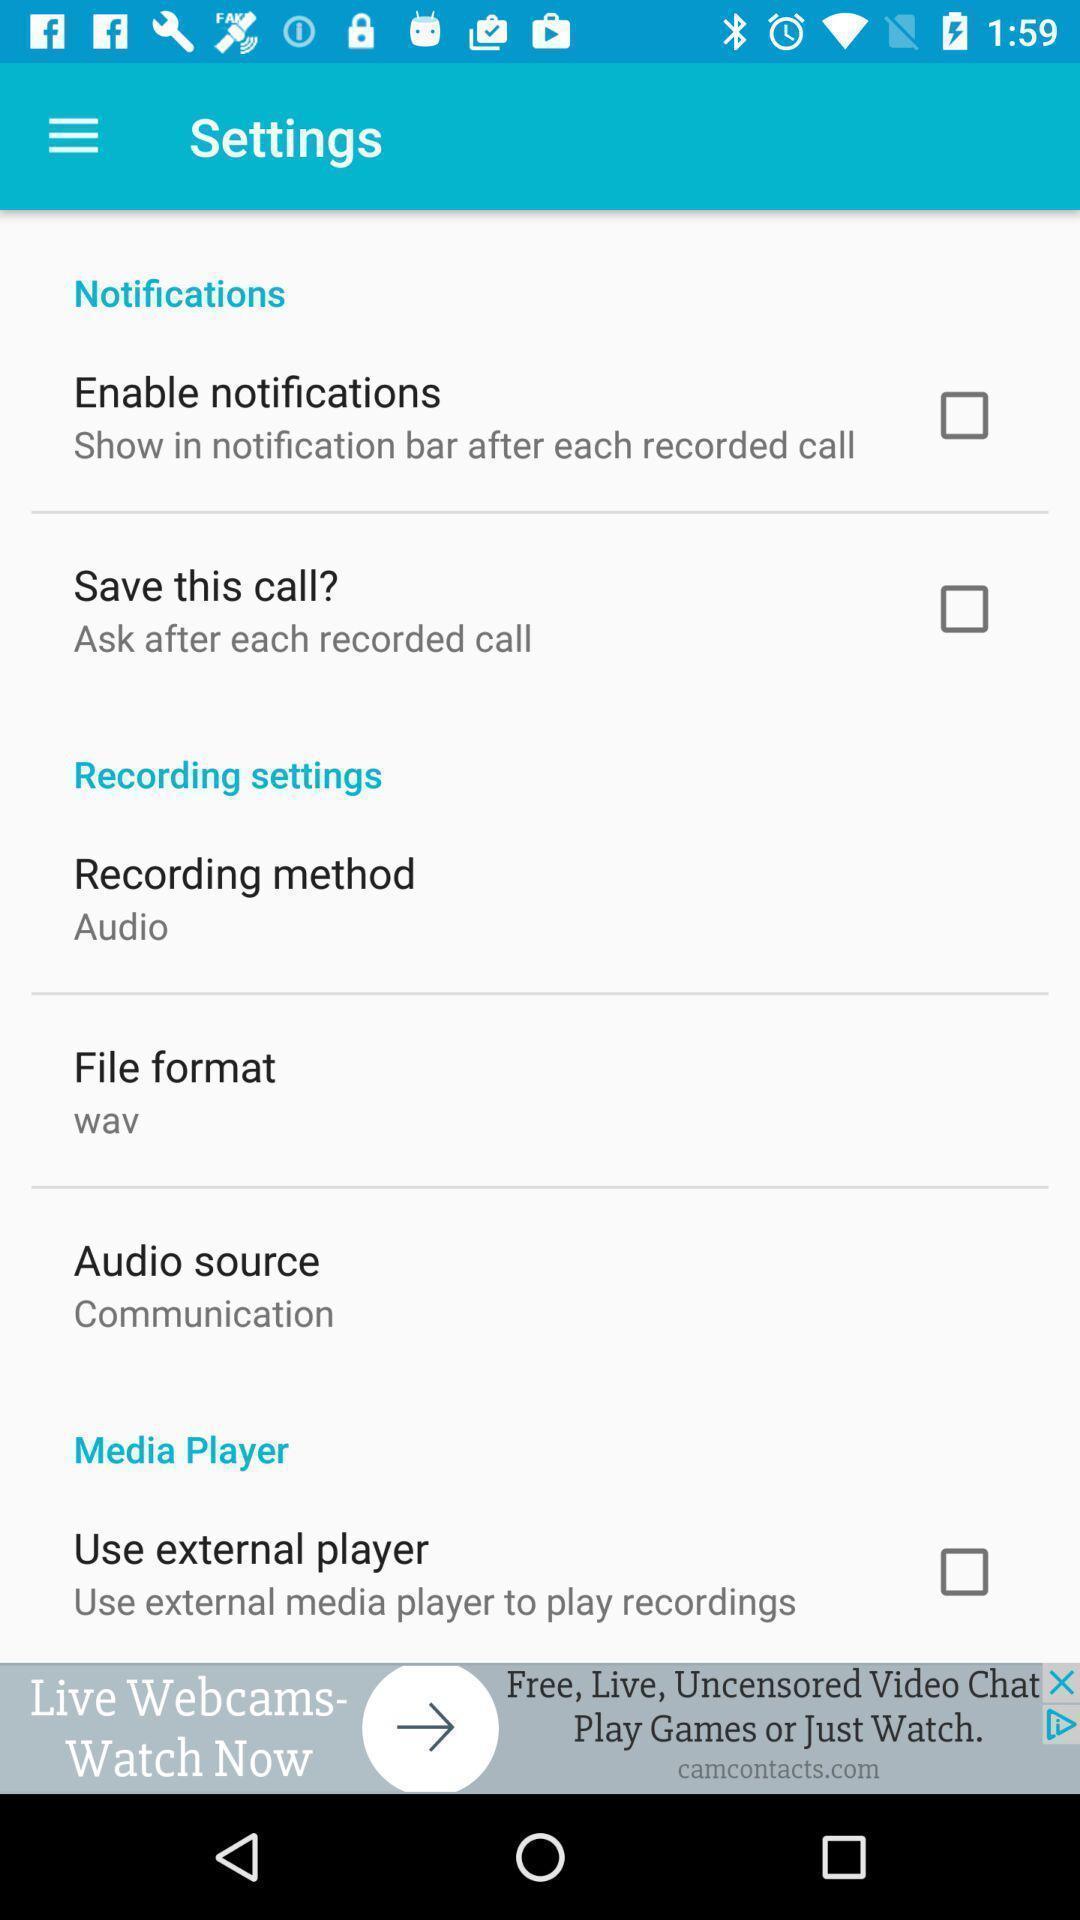Tell me about the visual elements in this screen capture. Settings page. 